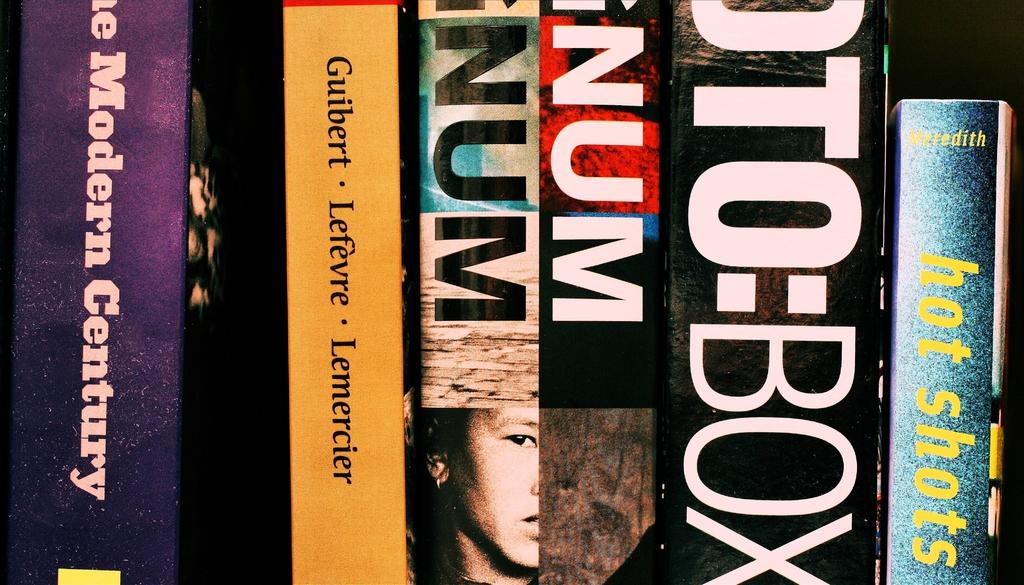Provide a one-sentence caption for the provided image. A book called Hot Shots has a sparkly blue spine. 